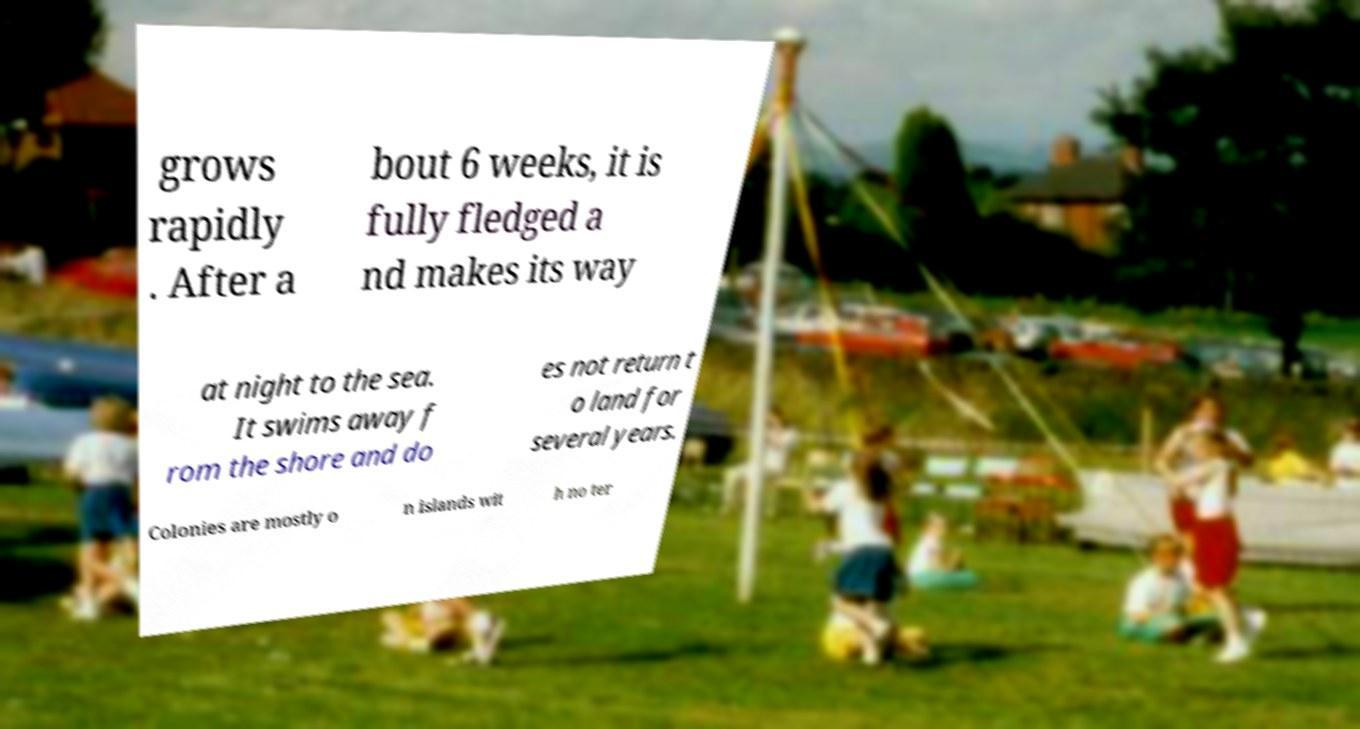There's text embedded in this image that I need extracted. Can you transcribe it verbatim? grows rapidly . After a bout 6 weeks, it is fully fledged a nd makes its way at night to the sea. It swims away f rom the shore and do es not return t o land for several years. Colonies are mostly o n islands wit h no ter 